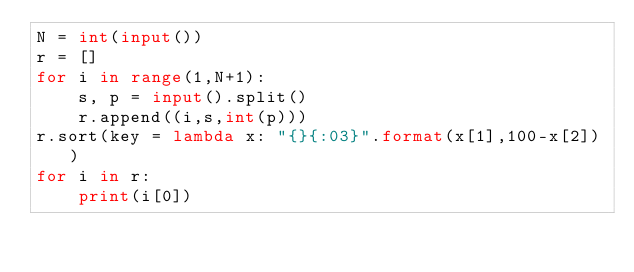<code> <loc_0><loc_0><loc_500><loc_500><_Python_>N = int(input())
r = []
for i in range(1,N+1):
    s, p = input().split()
    r.append((i,s,int(p)))
r.sort(key = lambda x: "{}{:03}".format(x[1],100-x[2]))
for i in r:
    print(i[0])</code> 